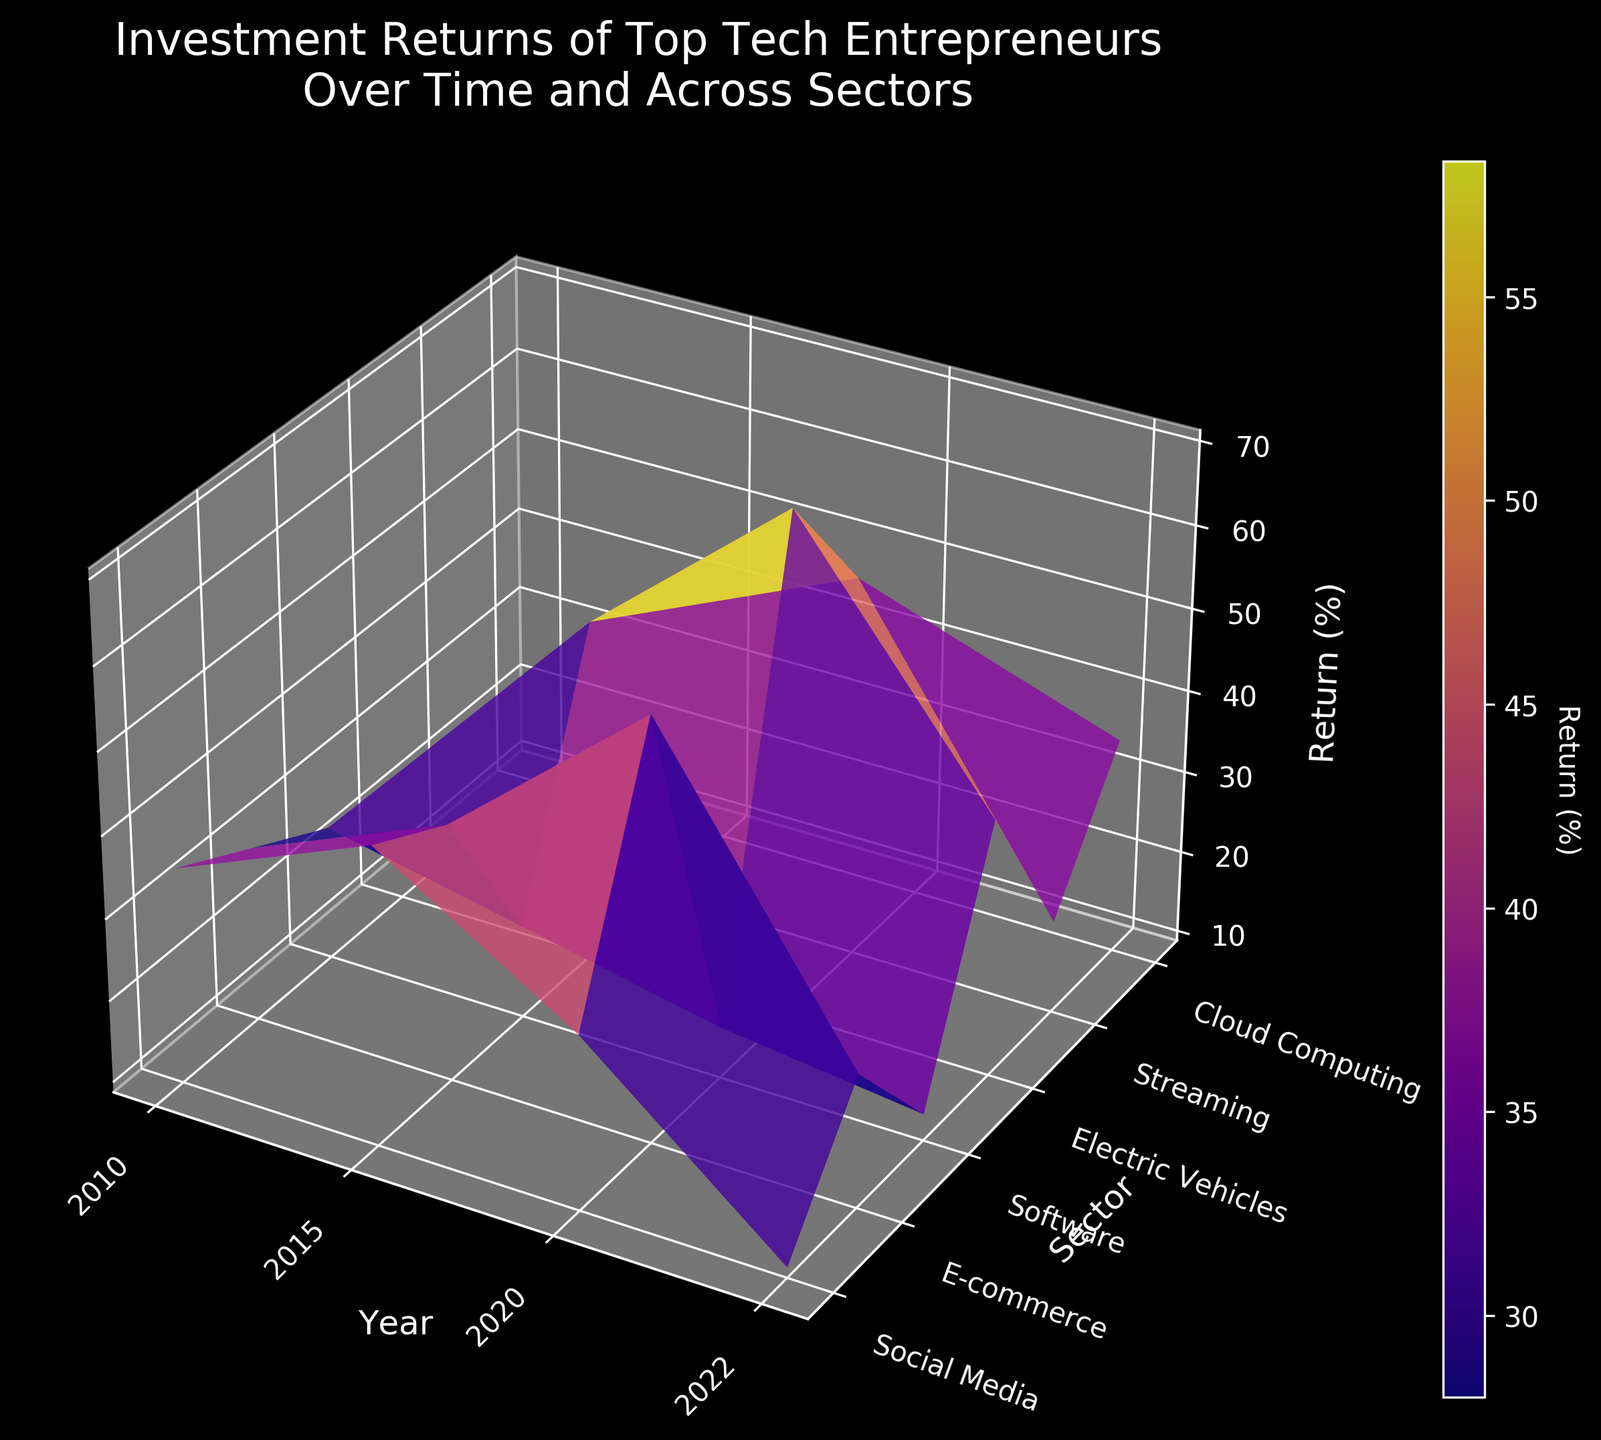What is the title of the figure? The title is located at the top of the figure and provides an overview of the plot's content. In this case, the title is "Investment Returns of Top Tech Entrepreneurs Over Time and Across Sectors".
Answer: Investment Returns of Top Tech Entrepreneurs Over Time and Across Sectors Which sector shows the highest average return in 2020? Locate the 2020 labels along the X-axis and identify the peak value on the Z-axis. The highest peak corresponds to the "Electric Vehicles" sector.
Answer: Electric Vehicles How does the return rate for Social Media change from 2010 to 2022? Follow the Social Media sector along the Y-axis and track its changes along the X-axis from 2010 to 2022. The returns start at 35% in 2010, peak at 45% in 2015, decrease to 30% in 2020, and drop significantly to 10% by 2022.
Answer: Decreases Which year shows the most significant drop in average return across all sectors? Identify the year along the X-axis where Z-values (returns) generally decrease for most sectors compared to the previous year. The year 2022 shows a noticeable drop across most sectors compared to 2020.
Answer: 2022 Between Mark Zuckerberg and Jeff Bezos, who had the higher returns in 2010 within their respective sectors? Look for the returns in 2010 along the X-axis for Social Media (Mark Zuckerberg) and E-commerce (Jeff Bezos). Mark Zuckerberg had a return of 35%, whereas Jeff Bezos had 30%.
Answer: Mark Zuckerberg Which sector has shown consistent growth in returns from 2015 to 2020? Track each sector along the Y-axis, checking returns for 2015 and then 2020 along the X-axis. "E-commerce" and "Electric Vehicles" show growth, but "Electric Vehicles" has more consistent and notable growth.
Answer: Electric Vehicles What does the color bar indicate about the return rates? The color bar provides a gradient that represents the range of return values, with different colors corresponding to different percentages. Brighter colors typically indicate higher returns.
Answer: Return (%) Which sector saw the most significant decrease in returns from 2020 to 2022? Follow the sectors along the Y-axis and compare the returns from 2020 to 2022. The "Social Media" sector shows the most pronounced decline.
Answer: Social Media What is the average return in the software sector in 2010 and 2022? Identify the average returns in the Software sector by locating 2010 and 2022 along the X-axis and Y-axis, and averaging the values for these years. The returns are 25% in 2010 and 12% in 2022. Average = (25 + 12) / 2 = 18.5%.
Answer: 18.5% Which entrepreneur’s sector saw the highest return in 2015? In 2015, locate the highest Z-value among the sectors. The "Electric Vehicles" sector had the highest return of 50%, associated with Elon Musk.
Answer: Elon Musk 